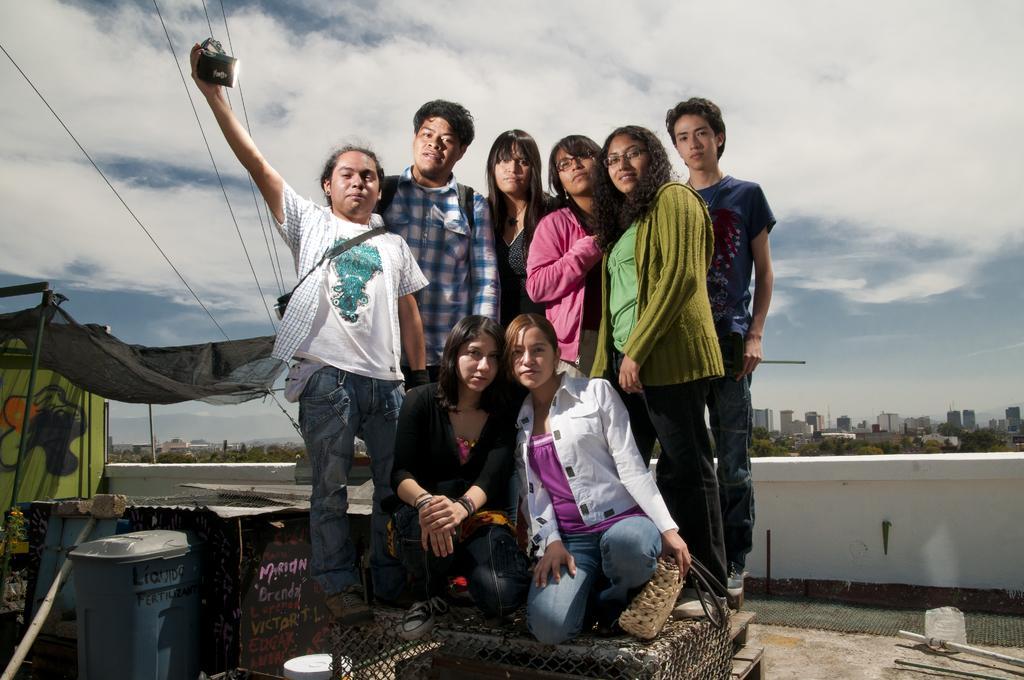Can you describe this image briefly? This is an outside view. Here I can see few people giving pose for the picture. Two women are sitting on the knees and remaining are standing on a metal object. On the left side there is a dustbin, tent and some other objects are placed. At the back of these people there is a wall. In the background there are many trees and buildings. At the top of the image I can see the sky and clouds. The person who is on the left side is holding an object in the hand. 